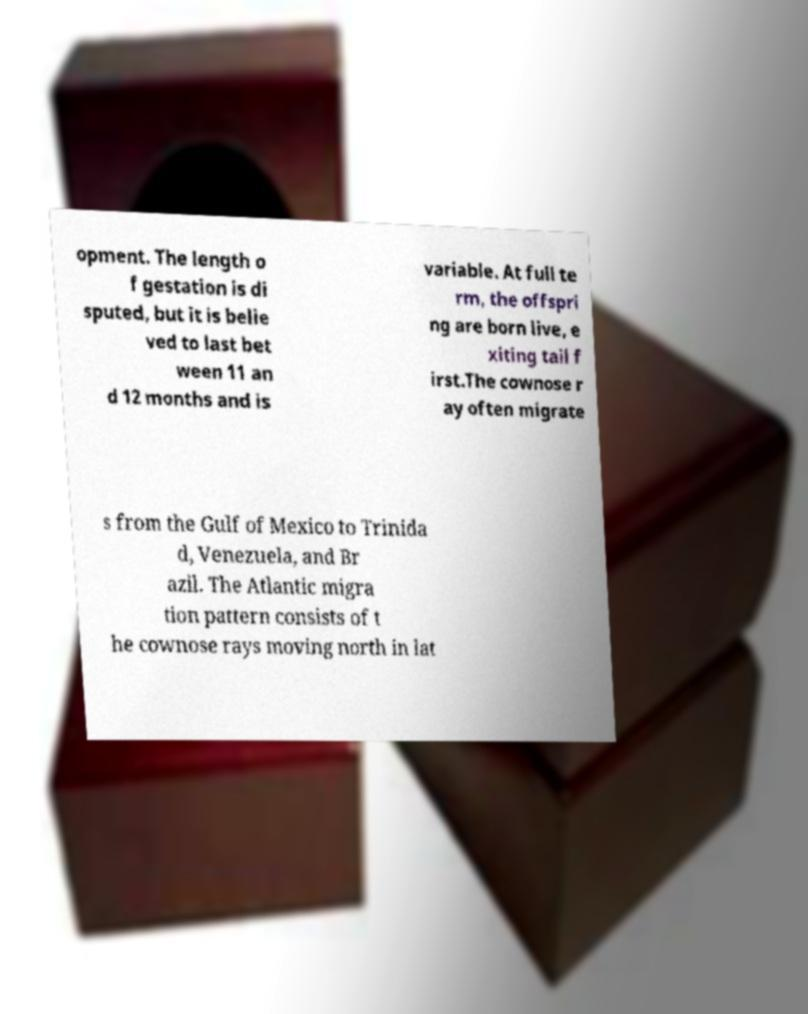Please read and relay the text visible in this image. What does it say? opment. The length o f gestation is di sputed, but it is belie ved to last bet ween 11 an d 12 months and is variable. At full te rm, the offspri ng are born live, e xiting tail f irst.The cownose r ay often migrate s from the Gulf of Mexico to Trinida d, Venezuela, and Br azil. The Atlantic migra tion pattern consists of t he cownose rays moving north in lat 